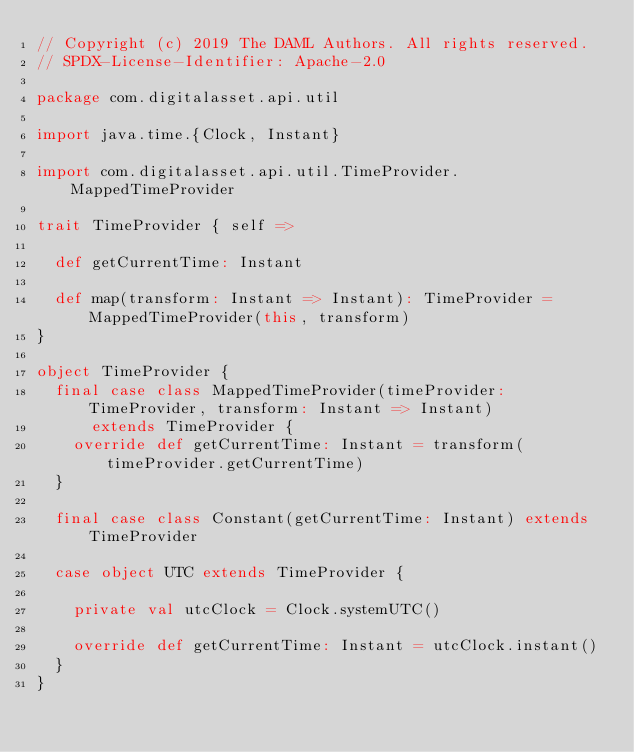Convert code to text. <code><loc_0><loc_0><loc_500><loc_500><_Scala_>// Copyright (c) 2019 The DAML Authors. All rights reserved.
// SPDX-License-Identifier: Apache-2.0

package com.digitalasset.api.util

import java.time.{Clock, Instant}

import com.digitalasset.api.util.TimeProvider.MappedTimeProvider

trait TimeProvider { self =>

  def getCurrentTime: Instant

  def map(transform: Instant => Instant): TimeProvider = MappedTimeProvider(this, transform)
}

object TimeProvider {
  final case class MappedTimeProvider(timeProvider: TimeProvider, transform: Instant => Instant)
      extends TimeProvider {
    override def getCurrentTime: Instant = transform(timeProvider.getCurrentTime)
  }

  final case class Constant(getCurrentTime: Instant) extends TimeProvider

  case object UTC extends TimeProvider {

    private val utcClock = Clock.systemUTC()

    override def getCurrentTime: Instant = utcClock.instant()
  }
}
</code> 